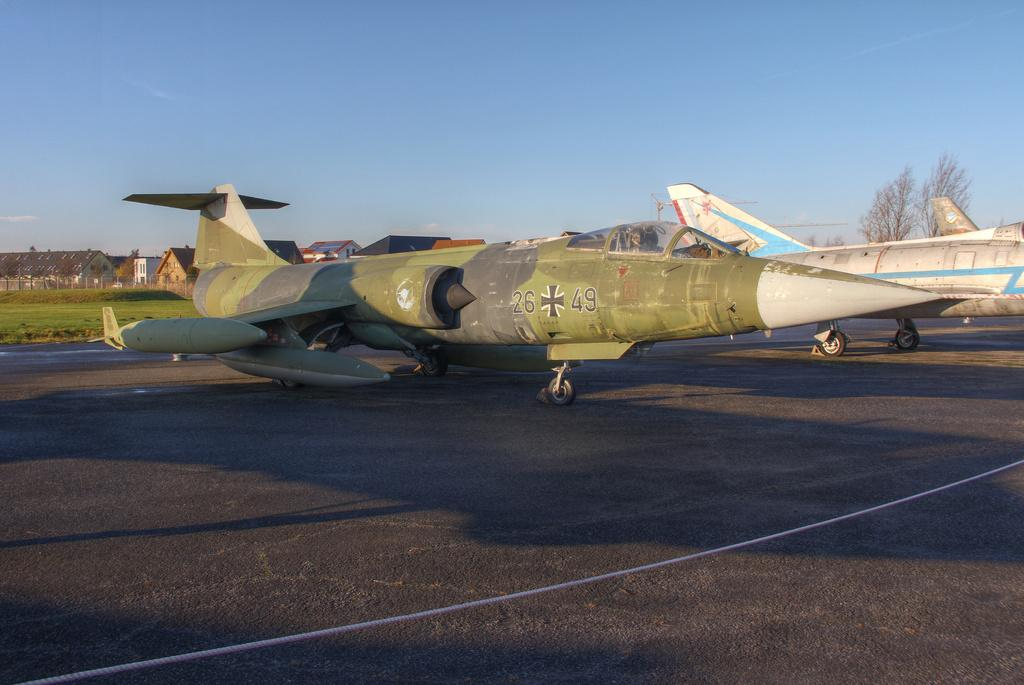<image>
Offer a succinct explanation of the picture presented. The numbers 26 and 49 are on the side of a plane on a runway. 